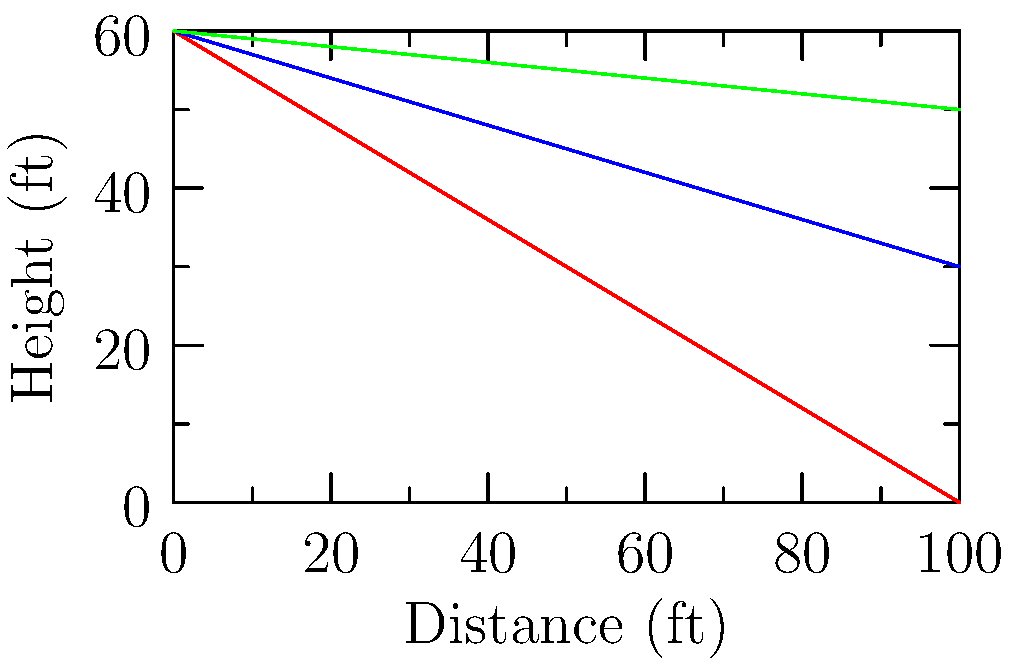Based on the graph showing the trajectories of different pitch types, which pitch has the most vertical drop from the release point to home plate? To determine which pitch has the most vertical drop, we need to analyze the trajectories of each pitch type:

1. Fastball (red line):
   - Starts at 60 ft height
   - Ends at 0 ft height
   - Total drop: 60 ft

2. Curveball (blue line):
   - Starts at 60 ft height
   - Ends at 30 ft height
   - Total drop: 30 ft

3. Slider (green line):
   - Starts at 60 ft height
   - Ends at 50 ft height
   - Total drop: 10 ft

Comparing the vertical drops:
- Fastball: 60 ft
- Curveball: 30 ft
- Slider: 10 ft

The pitch with the most vertical drop is the fastball, with a 60 ft drop from release point to home plate.
Answer: Fastball 